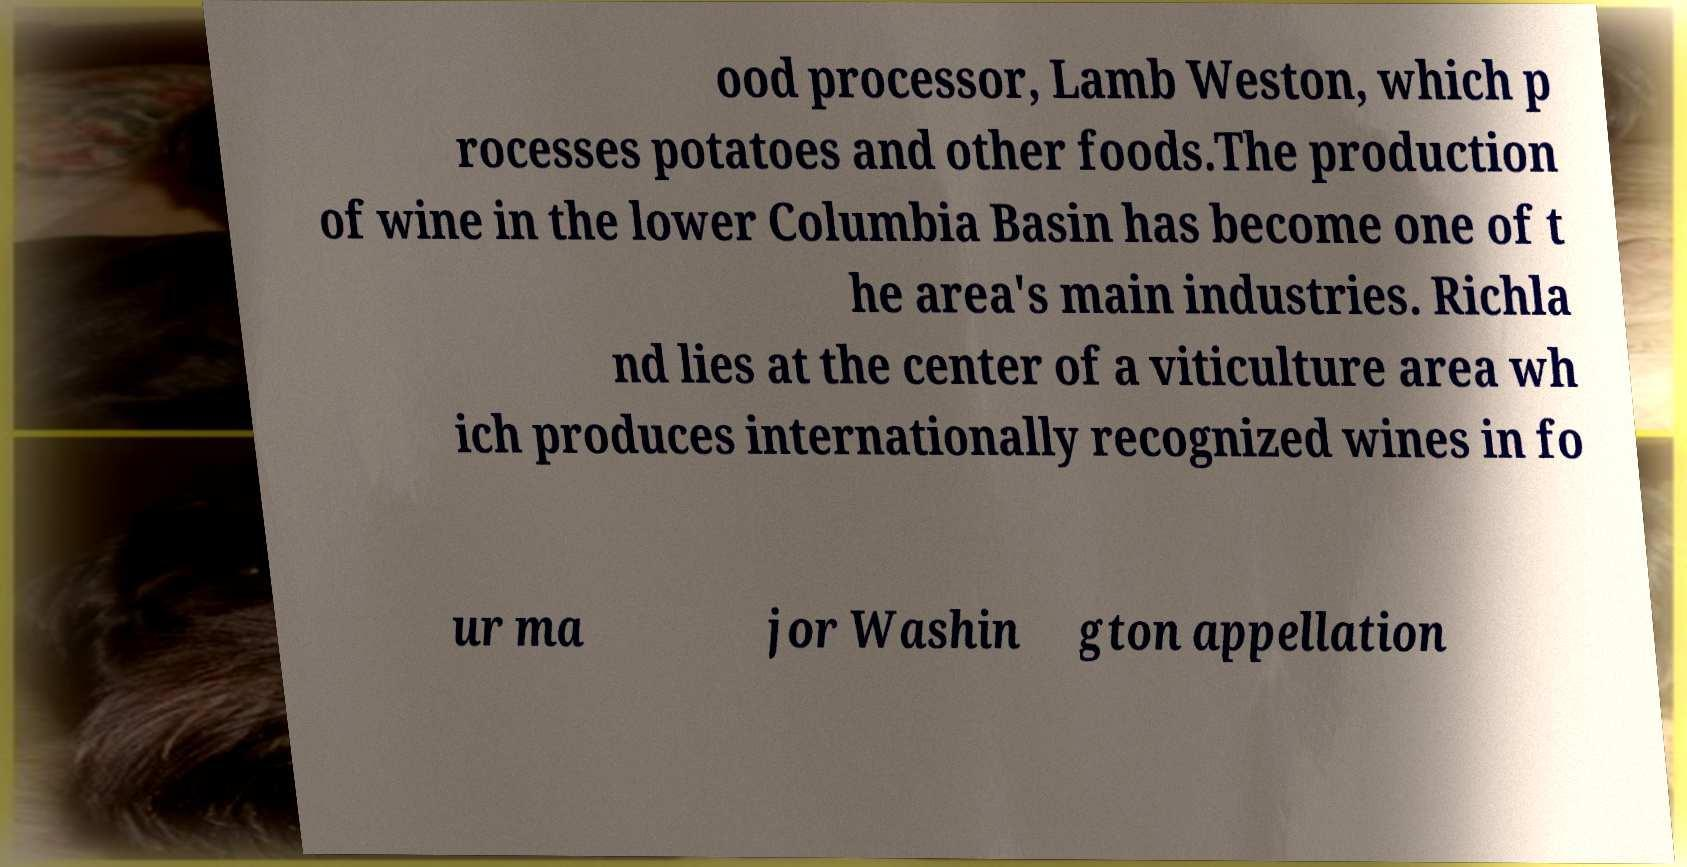There's text embedded in this image that I need extracted. Can you transcribe it verbatim? ood processor, Lamb Weston, which p rocesses potatoes and other foods.The production of wine in the lower Columbia Basin has become one of t he area's main industries. Richla nd lies at the center of a viticulture area wh ich produces internationally recognized wines in fo ur ma jor Washin gton appellation 